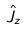<formula> <loc_0><loc_0><loc_500><loc_500>\hat { J } _ { z }</formula> 